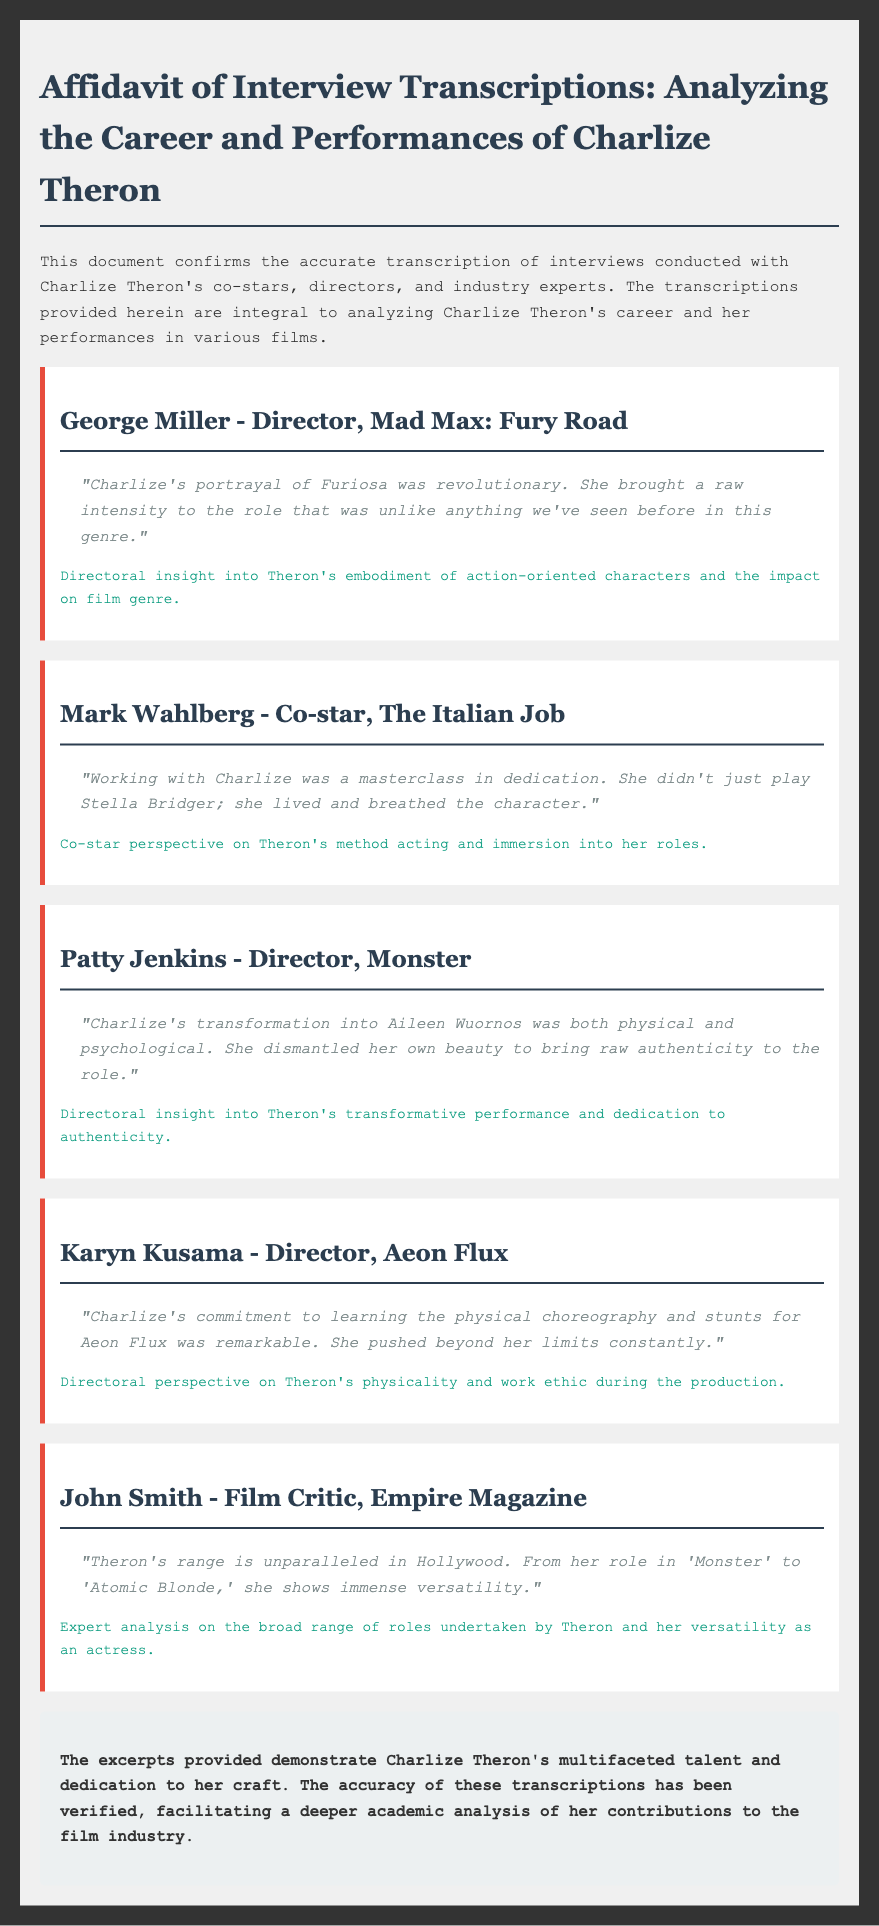What is the title of the document? The title of the document is presented in the header.
Answer: Affidavit of Interview Transcriptions: Analyzing the Career and Performances of Charlize Theron Who directed Mad Max: Fury Road? The director's name is mentioned alongside the interview section.
Answer: George Miller In which film did Charlize Theron play a character named Aileen Wuornos? The film is named in the directorial insight excerpt.
Answer: Monster What was noted about Charlize Theron's performance in Aeon Flux? This is highlighted in Karyn Kusama's interview section.
Answer: Commitment to learning the physical choreography and stunts Which film critic provided insight on Theron's versatility? The critic's name is provided in the respective excerpt.
Answer: John Smith How did Patty Jenkins describe Theron's transformation for Monster? The description is given in Jenkins' interview.
Answer: Both physical and psychological What character did Mark Wahlberg say Charlize Theron lived and breathed? The character is referred to in Mark Wahlberg's interview.
Answer: Stella Bridger What is emphasized about Charlize Theron's range in Hollywood? This analysis is found in John Smith's excerpt.
Answer: Unparalleled What does the conclusion highlight about the transcriptions? The conclusion summarizes the significance of the transcriptions.
Answer: Accuracy verified 